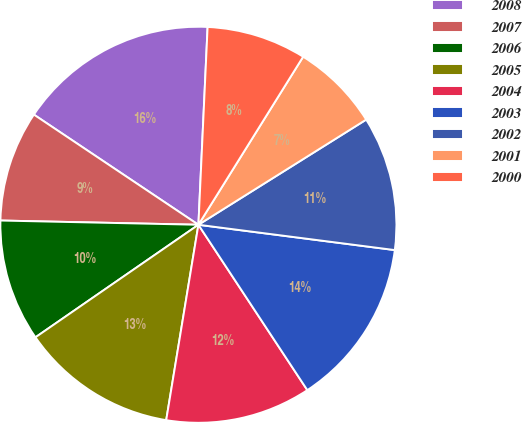Convert chart. <chart><loc_0><loc_0><loc_500><loc_500><pie_chart><fcel>2008<fcel>2007<fcel>2006<fcel>2005<fcel>2004<fcel>2003<fcel>2002<fcel>2001<fcel>2000<nl><fcel>16.35%<fcel>9.05%<fcel>9.96%<fcel>12.78%<fcel>11.87%<fcel>13.69%<fcel>10.95%<fcel>7.22%<fcel>8.13%<nl></chart> 